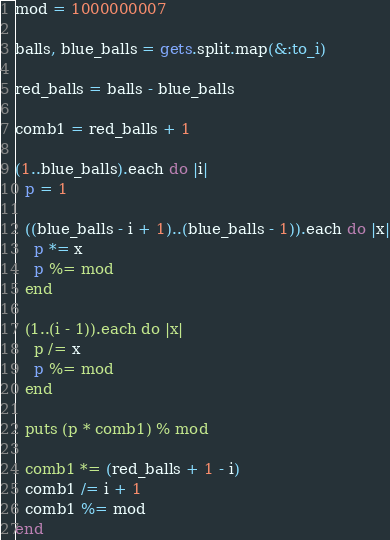<code> <loc_0><loc_0><loc_500><loc_500><_Ruby_>mod = 1000000007

balls, blue_balls = gets.split.map(&:to_i)

red_balls = balls - blue_balls

comb1 = red_balls + 1

(1..blue_balls).each do |i|
  p = 1
  
  ((blue_balls - i + 1)..(blue_balls - 1)).each do |x|
    p *= x
    p %= mod
  end
  
  (1..(i - 1)).each do |x|
    p /= x
    p %= mod
  end
  
  puts (p * comb1) % mod
  
  comb1 *= (red_balls + 1 - i)
  comb1 /= i + 1
  comb1 %= mod
end</code> 